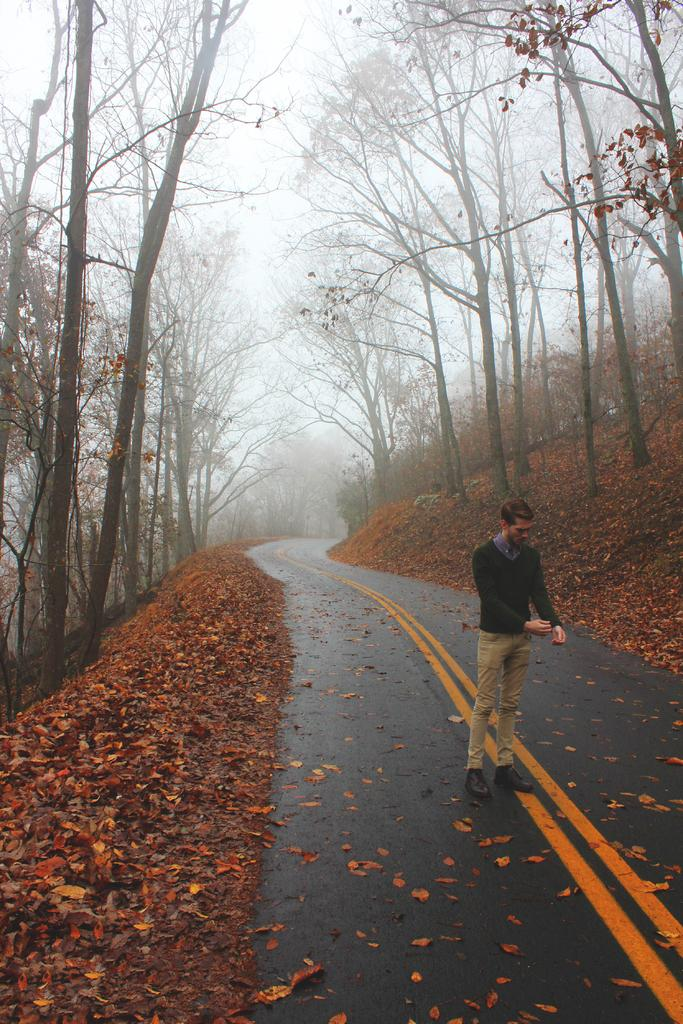What is the main subject of the image? There is a person standing on the road in the image. What can be seen in the background of the image? There are trees in the background of the image. What is present on the ground in the image? Leaves are visible on the ground in the image. How many basketball units are visible in the image? There are no basketball units present in the image. What type of apples can be seen growing on the trees in the image? There are no apples or trees with apples visible in the image. 